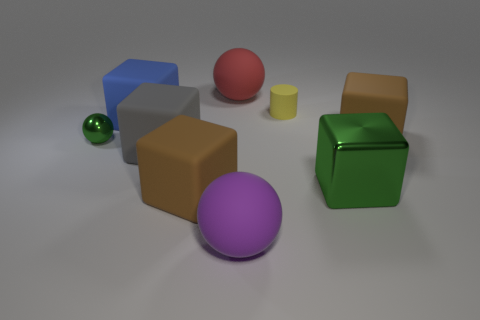The big object that is the same color as the metallic sphere is what shape?
Give a very brief answer. Cube. Is there a shiny object of the same color as the small shiny sphere?
Provide a succinct answer. Yes. What is the material of the tiny thing in front of the large brown rubber thing that is behind the green object on the right side of the tiny yellow object?
Offer a terse response. Metal. How many spheres are either rubber objects or big objects?
Provide a short and direct response. 2. Is there any other thing that is the same shape as the yellow matte object?
Keep it short and to the point. No. Are there more metallic blocks that are in front of the small green object than big blue rubber cubes behind the big red matte thing?
Provide a succinct answer. Yes. What number of blocks are in front of the large brown cube that is in front of the large metallic thing?
Your response must be concise. 0. How many things are either tiny yellow matte objects or brown blocks?
Ensure brevity in your answer.  3. Is the tiny yellow rubber thing the same shape as the large blue thing?
Offer a terse response. No. What material is the tiny green thing?
Your response must be concise. Metal. 